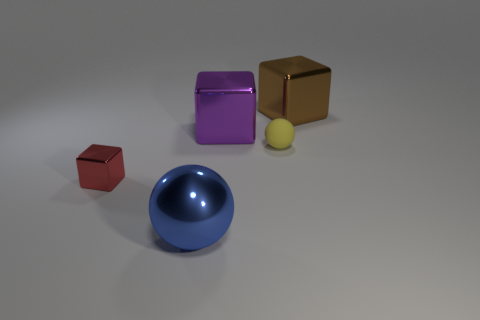Can you describe the lighting in the scene? The lighting in the scene appears to be diffuse, with a soft shadow cast beneath each object, suggesting an overhead source. There is no harsh direct lighting or strong specular highlights, which creates a calm, even illumination throughout the scene. The shadows and subtle light gradients enhance the objects' three-dimensional forms and contribute to the overall serene and balanced atmosphere. 